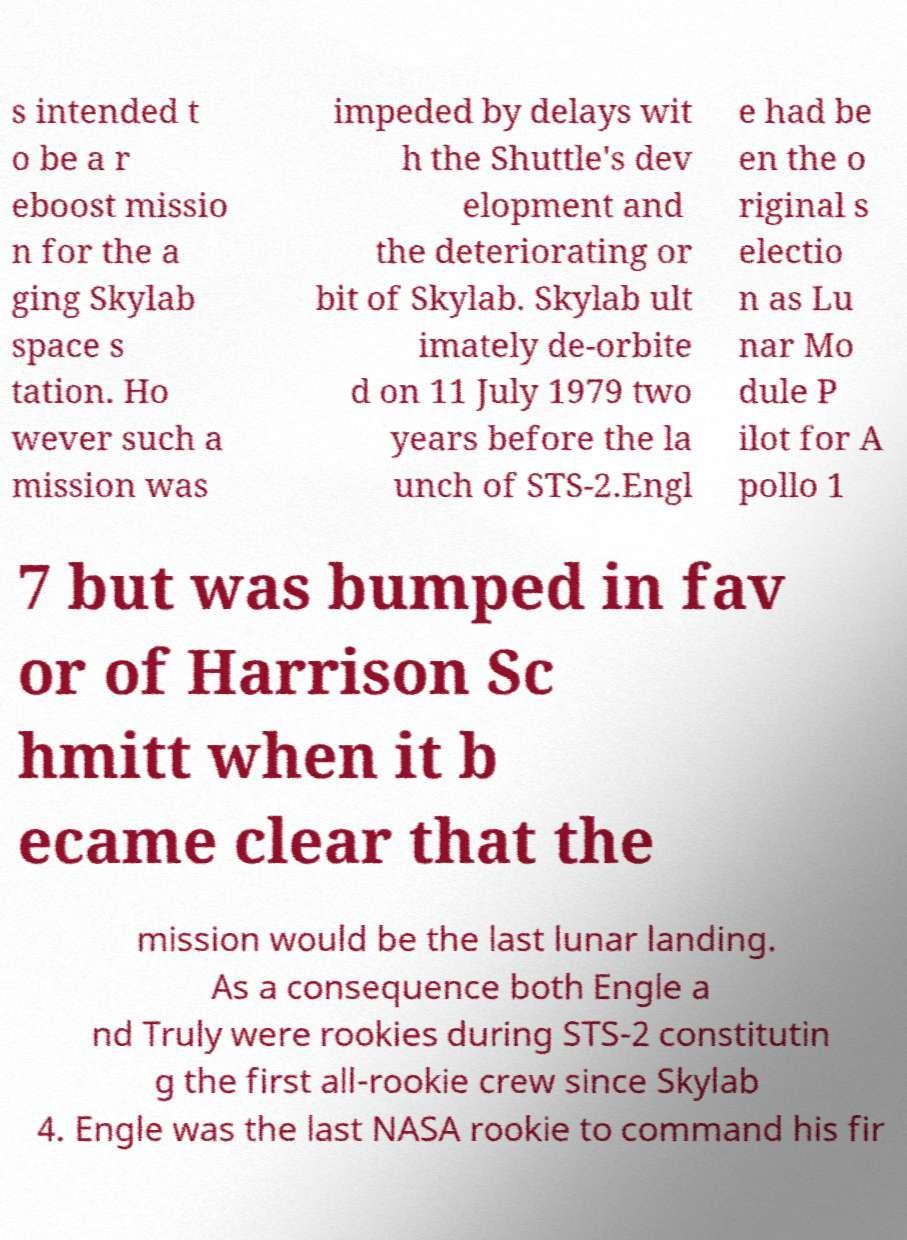Please identify and transcribe the text found in this image. s intended t o be a r eboost missio n for the a ging Skylab space s tation. Ho wever such a mission was impeded by delays wit h the Shuttle's dev elopment and the deteriorating or bit of Skylab. Skylab ult imately de-orbite d on 11 July 1979 two years before the la unch of STS-2.Engl e had be en the o riginal s electio n as Lu nar Mo dule P ilot for A pollo 1 7 but was bumped in fav or of Harrison Sc hmitt when it b ecame clear that the mission would be the last lunar landing. As a consequence both Engle a nd Truly were rookies during STS-2 constitutin g the first all-rookie crew since Skylab 4. Engle was the last NASA rookie to command his fir 